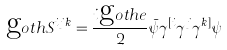Convert formula to latex. <formula><loc_0><loc_0><loc_500><loc_500>\text  goth{S} ^ { i j k } = \frac { i \text  goth{e} } { 2 } \bar { \psi } \gamma ^ { [ i } \gamma ^ { j } \gamma ^ { k ] } \psi</formula> 